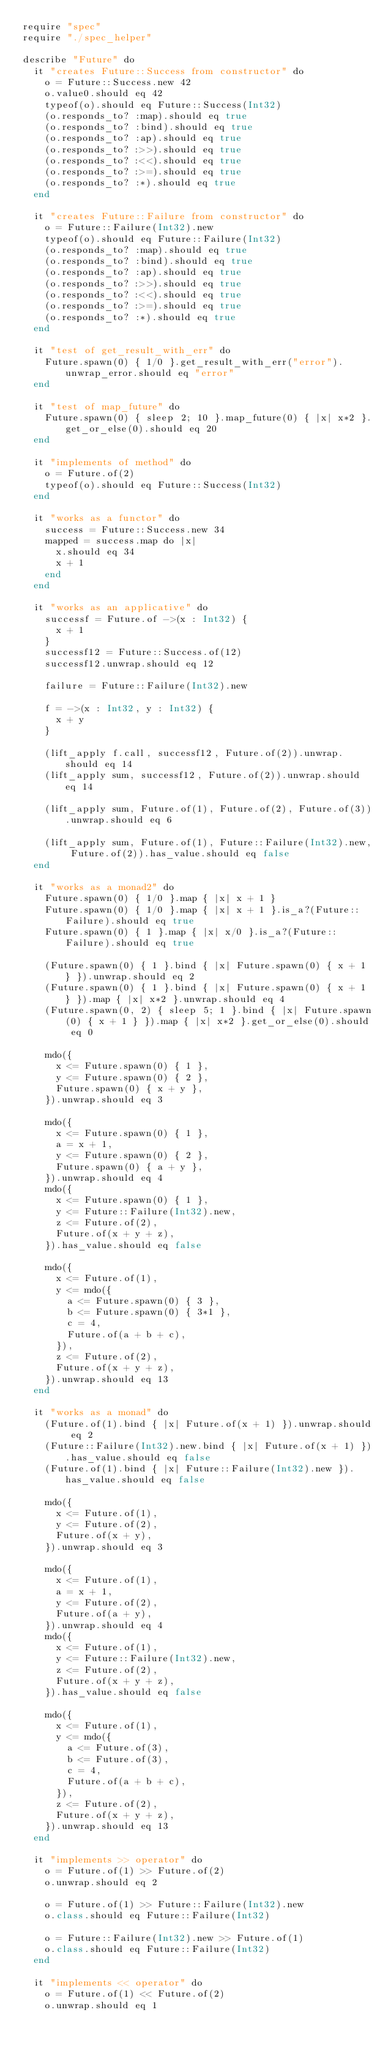<code> <loc_0><loc_0><loc_500><loc_500><_Crystal_>require "spec"
require "./spec_helper"

describe "Future" do
  it "creates Future::Success from constructor" do
    o = Future::Success.new 42
    o.value0.should eq 42
    typeof(o).should eq Future::Success(Int32)
    (o.responds_to? :map).should eq true
    (o.responds_to? :bind).should eq true
    (o.responds_to? :ap).should eq true
    (o.responds_to? :>>).should eq true
    (o.responds_to? :<<).should eq true
    (o.responds_to? :>=).should eq true
    (o.responds_to? :*).should eq true
  end

  it "creates Future::Failure from constructor" do
    o = Future::Failure(Int32).new
    typeof(o).should eq Future::Failure(Int32)
    (o.responds_to? :map).should eq true
    (o.responds_to? :bind).should eq true
    (o.responds_to? :ap).should eq true
    (o.responds_to? :>>).should eq true
    (o.responds_to? :<<).should eq true
    (o.responds_to? :>=).should eq true
    (o.responds_to? :*).should eq true
  end

  it "test of get_result_with_err" do
    Future.spawn(0) { 1/0 }.get_result_with_err("error").unwrap_error.should eq "error"
  end

  it "test of map_future" do
    Future.spawn(0) { sleep 2; 10 }.map_future(0) { |x| x*2 }.get_or_else(0).should eq 20
  end

  it "implements of method" do
    o = Future.of(2)
    typeof(o).should eq Future::Success(Int32)
  end

  it "works as a functor" do
    success = Future::Success.new 34
    mapped = success.map do |x|
      x.should eq 34
      x + 1
    end
  end

  it "works as an applicative" do
    successf = Future.of ->(x : Int32) {
      x + 1
    }
    successf12 = Future::Success.of(12)
    successf12.unwrap.should eq 12

    failure = Future::Failure(Int32).new

    f = ->(x : Int32, y : Int32) {
      x + y
    }

    (lift_apply f.call, successf12, Future.of(2)).unwrap.should eq 14
    (lift_apply sum, successf12, Future.of(2)).unwrap.should eq 14

    (lift_apply sum, Future.of(1), Future.of(2), Future.of(3)).unwrap.should eq 6

    (lift_apply sum, Future.of(1), Future::Failure(Int32).new, Future.of(2)).has_value.should eq false
  end

  it "works as a monad2" do
    Future.spawn(0) { 1/0 }.map { |x| x + 1 }
    Future.spawn(0) { 1/0 }.map { |x| x + 1 }.is_a?(Future::Failure).should eq true
    Future.spawn(0) { 1 }.map { |x| x/0 }.is_a?(Future::Failure).should eq true

    (Future.spawn(0) { 1 }.bind { |x| Future.spawn(0) { x + 1 } }).unwrap.should eq 2
    (Future.spawn(0) { 1 }.bind { |x| Future.spawn(0) { x + 1 } }).map { |x| x*2 }.unwrap.should eq 4
    (Future.spawn(0, 2) { sleep 5; 1 }.bind { |x| Future.spawn(0) { x + 1 } }).map { |x| x*2 }.get_or_else(0).should eq 0

    mdo({
      x <= Future.spawn(0) { 1 },
      y <= Future.spawn(0) { 2 },
      Future.spawn(0) { x + y },
    }).unwrap.should eq 3

    mdo({
      x <= Future.spawn(0) { 1 },
      a = x + 1,
      y <= Future.spawn(0) { 2 },
      Future.spawn(0) { a + y },
    }).unwrap.should eq 4
    mdo({
      x <= Future.spawn(0) { 1 },
      y <= Future::Failure(Int32).new,
      z <= Future.of(2),
      Future.of(x + y + z),
    }).has_value.should eq false

    mdo({
      x <= Future.of(1),
      y <= mdo({
        a <= Future.spawn(0) { 3 },
        b <= Future.spawn(0) { 3*1 },
        c = 4,
        Future.of(a + b + c),
      }),
      z <= Future.of(2),
      Future.of(x + y + z),
    }).unwrap.should eq 13
  end

  it "works as a monad" do
    (Future.of(1).bind { |x| Future.of(x + 1) }).unwrap.should eq 2
    (Future::Failure(Int32).new.bind { |x| Future.of(x + 1) }).has_value.should eq false
    (Future.of(1).bind { |x| Future::Failure(Int32).new }).has_value.should eq false

    mdo({
      x <= Future.of(1),
      y <= Future.of(2),
      Future.of(x + y),
    }).unwrap.should eq 3

    mdo({
      x <= Future.of(1),
      a = x + 1,
      y <= Future.of(2),
      Future.of(a + y),
    }).unwrap.should eq 4
    mdo({
      x <= Future.of(1),
      y <= Future::Failure(Int32).new,
      z <= Future.of(2),
      Future.of(x + y + z),
    }).has_value.should eq false

    mdo({
      x <= Future.of(1),
      y <= mdo({
        a <= Future.of(3),
        b <= Future.of(3),
        c = 4,
        Future.of(a + b + c),
      }),
      z <= Future.of(2),
      Future.of(x + y + z),
    }).unwrap.should eq 13
  end

  it "implements >> operator" do
    o = Future.of(1) >> Future.of(2)
    o.unwrap.should eq 2

    o = Future.of(1) >> Future::Failure(Int32).new
    o.class.should eq Future::Failure(Int32)

    o = Future::Failure(Int32).new >> Future.of(1)
    o.class.should eq Future::Failure(Int32)
  end

  it "implements << operator" do
    o = Future.of(1) << Future.of(2)
    o.unwrap.should eq 1
</code> 